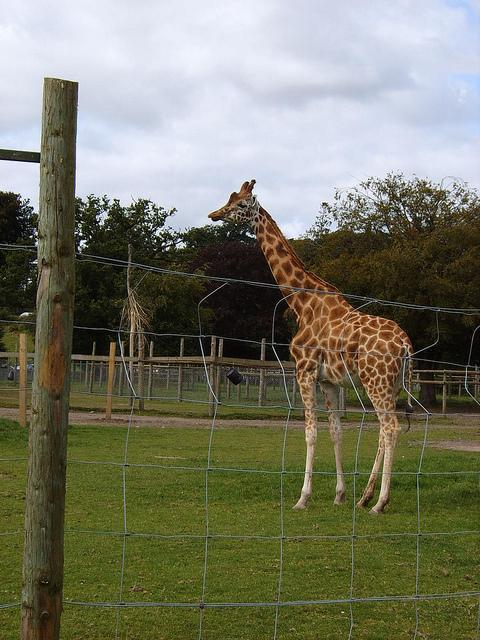Is there a fence around the animal?
Give a very brief answer. Yes. Is this a street corner?
Be succinct. No. How many spots are on the giraffe?
Answer briefly. Lot. 